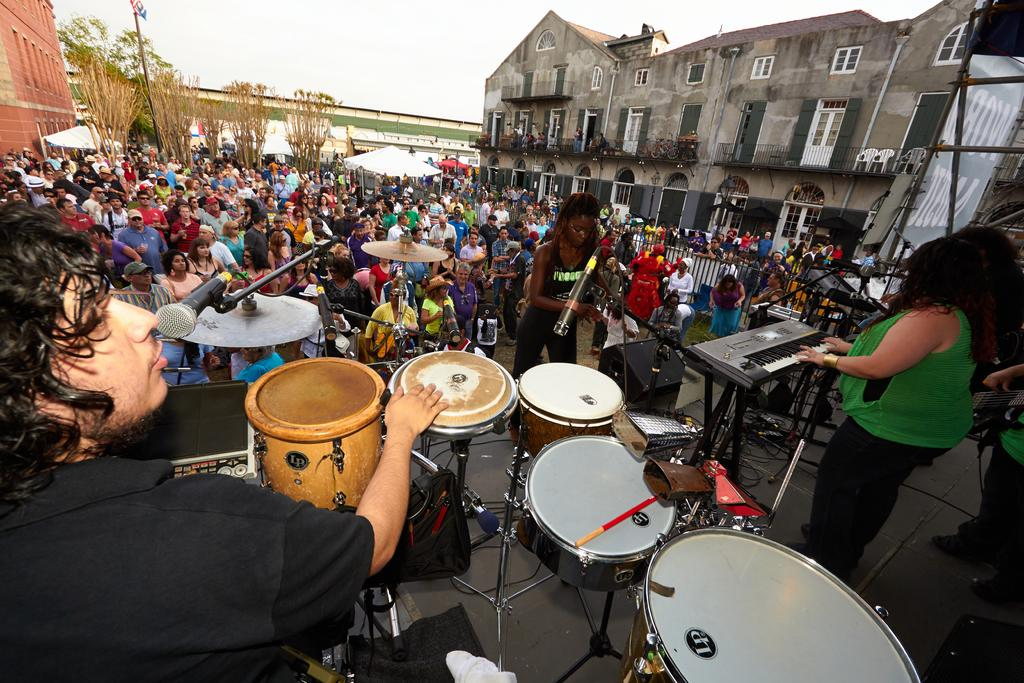How many people are in the image? There is a group of people in the image. What are two people in the group doing? Two people in the group are playing musical instruments. What type of structures can be seen in the image? There are buildings visible in the image. What type of vegetation is present in the image? There are trees in the image. What is the health condition of the airplane in the image? There is no airplane present in the image, so it is not possible to determine its health condition. 